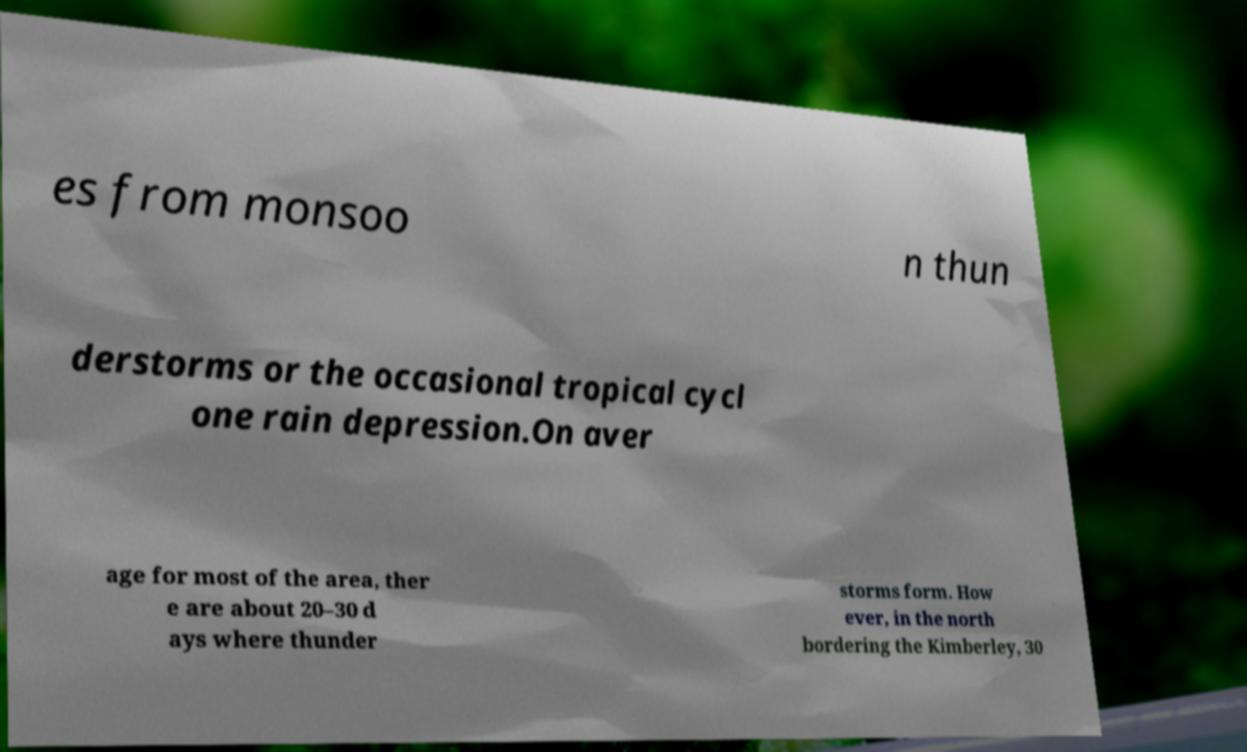I need the written content from this picture converted into text. Can you do that? es from monsoo n thun derstorms or the occasional tropical cycl one rain depression.On aver age for most of the area, ther e are about 20–30 d ays where thunder storms form. How ever, in the north bordering the Kimberley, 30 